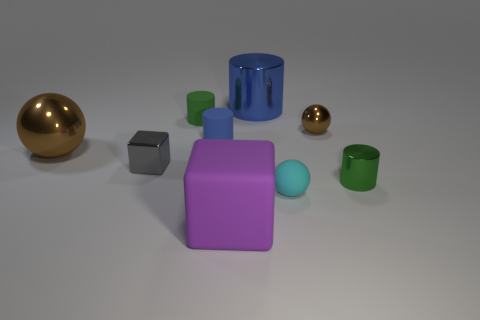Subtract all blocks. How many objects are left? 7 Add 5 small shiny balls. How many small shiny balls exist? 6 Subtract 1 brown spheres. How many objects are left? 8 Subtract all blue rubber things. Subtract all small matte cylinders. How many objects are left? 6 Add 2 blue rubber cylinders. How many blue rubber cylinders are left? 3 